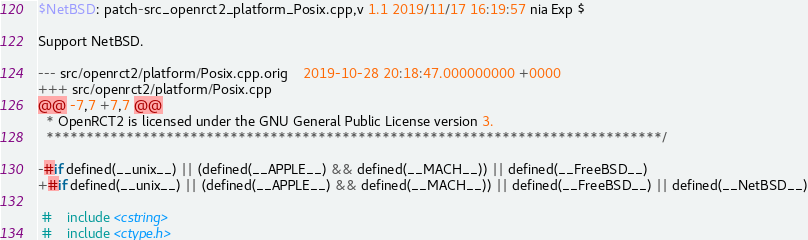Convert code to text. <code><loc_0><loc_0><loc_500><loc_500><_C++_>$NetBSD: patch-src_openrct2_platform_Posix.cpp,v 1.1 2019/11/17 16:19:57 nia Exp $

Support NetBSD.

--- src/openrct2/platform/Posix.cpp.orig	2019-10-28 20:18:47.000000000 +0000
+++ src/openrct2/platform/Posix.cpp
@@ -7,7 +7,7 @@
  * OpenRCT2 is licensed under the GNU General Public License version 3.
  *****************************************************************************/
 
-#if defined(__unix__) || (defined(__APPLE__) && defined(__MACH__)) || defined(__FreeBSD__)
+#if defined(__unix__) || (defined(__APPLE__) && defined(__MACH__)) || defined(__FreeBSD__) || defined(__NetBSD__)
 
 #    include <cstring>
 #    include <ctype.h>
</code> 